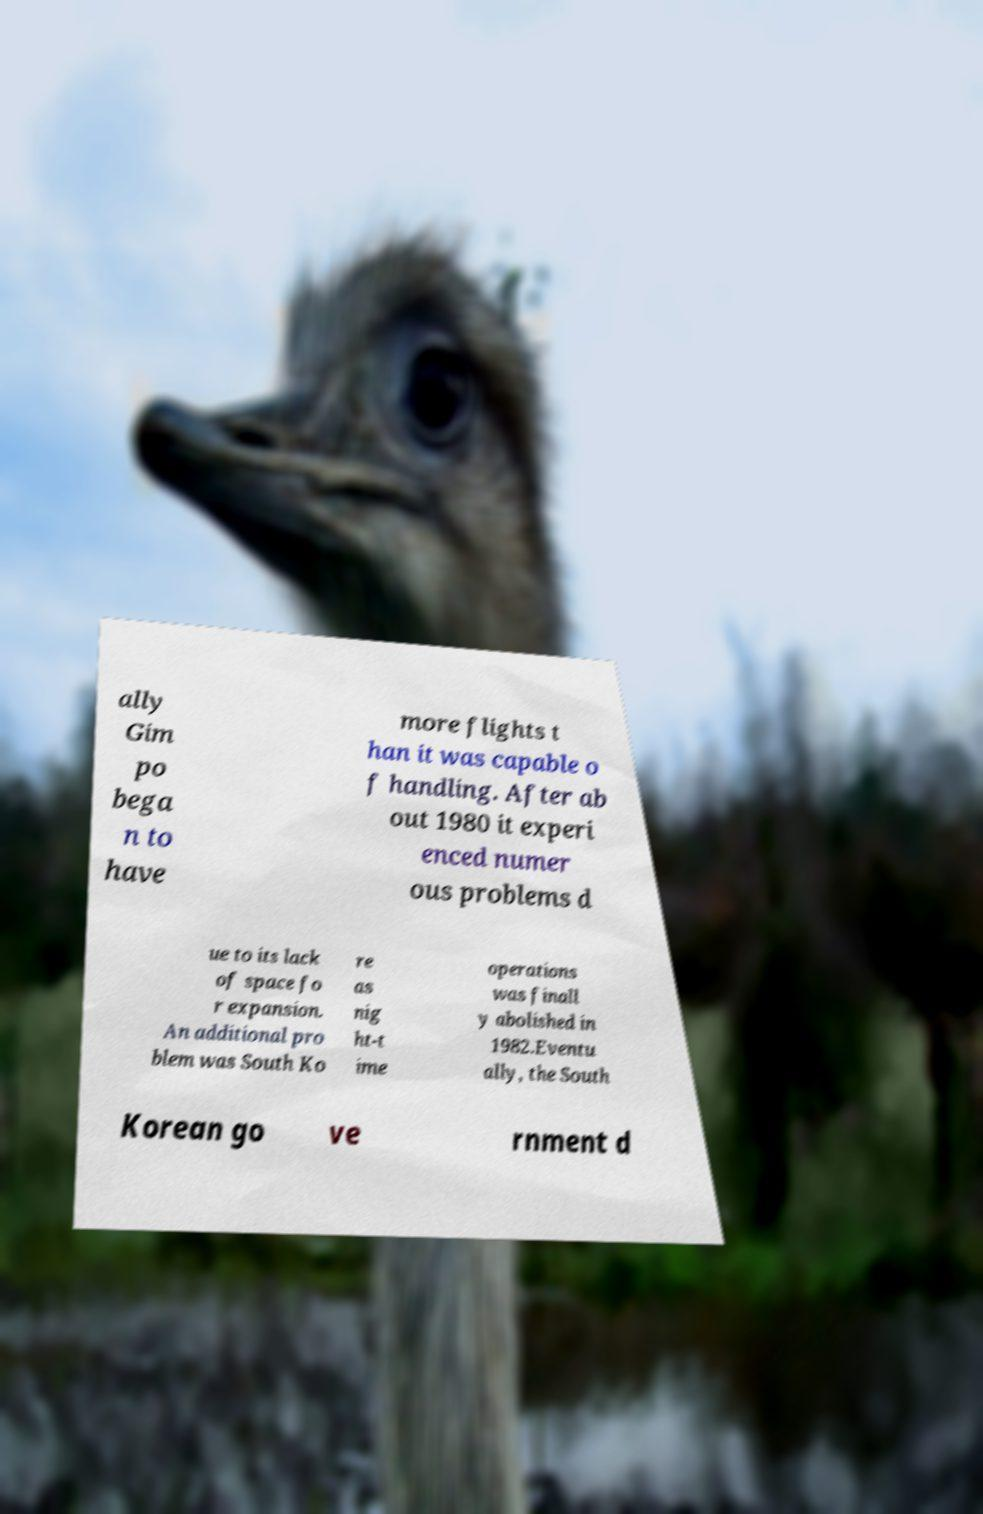There's text embedded in this image that I need extracted. Can you transcribe it verbatim? ally Gim po bega n to have more flights t han it was capable o f handling. After ab out 1980 it experi enced numer ous problems d ue to its lack of space fo r expansion. An additional pro blem was South Ko re as nig ht-t ime operations was finall y abolished in 1982.Eventu ally, the South Korean go ve rnment d 